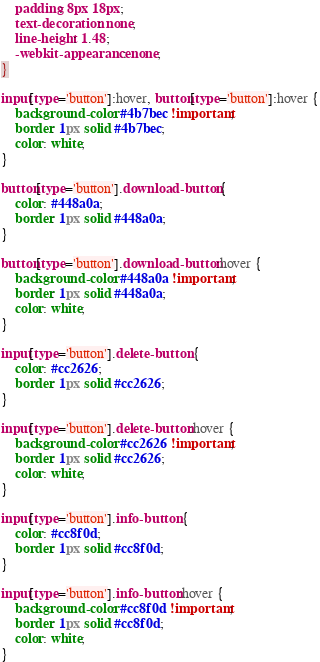Convert code to text. <code><loc_0><loc_0><loc_500><loc_500><_CSS_>	padding: 8px 18px;
	text-decoration: none;
	line-height: 1.48;
	-webkit-appearance: none;
}

input[type='button']:hover, button[type='button']:hover {
	background-color: #4b7bec !important;
	border: 1px solid #4b7bec;
	color: white;
}

button[type='button'].download-button {
	color: #448a0a;
	border: 1px solid #448a0a;
}

button[type='button'].download-button:hover {
	background-color: #448a0a !important;
	border: 1px solid #448a0a;
	color: white;
}

input[type='button'].delete-button {
	color: #cc2626;
	border: 1px solid #cc2626;
}

input[type='button'].delete-button:hover {
	background-color: #cc2626 !important;
	border: 1px solid #cc2626;
	color: white;
}

input[type='button'].info-button {
	color: #cc8f0d;
	border: 1px solid #cc8f0d;
}

input[type='button'].info-button:hover {
	background-color: #cc8f0d !important;
	border: 1px solid #cc8f0d;
	color: white;
}</code> 